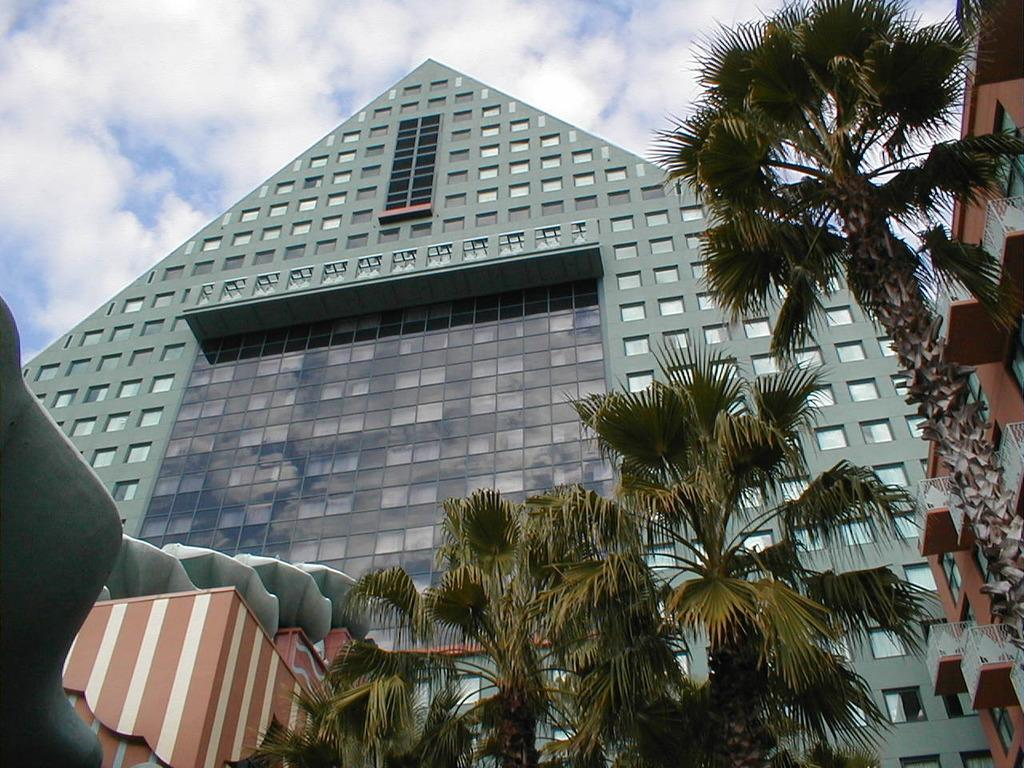What type of structures can be seen in the image? There are buildings in the image. What other natural elements are present in the image? There are trees in the image. What architectural feature can be seen in the image? Railings are visible in the image. What part of the buildings can be seen in the image? Windows are present in the image. What is visible in the background of the image? The sky is visible in the background of the image. What can be observed in the sky? Clouds are present in the sky. What type of house is being built in the image? There is no house being built in the image; it features existing buildings and trees. What is the process of constructing the house in the image? There is no house construction process in the image, as it only shows existing structures and natural elements. 